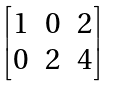Convert formula to latex. <formula><loc_0><loc_0><loc_500><loc_500>\begin{bmatrix} 1 & 0 & 2 \\ 0 & 2 & 4 \end{bmatrix}</formula> 